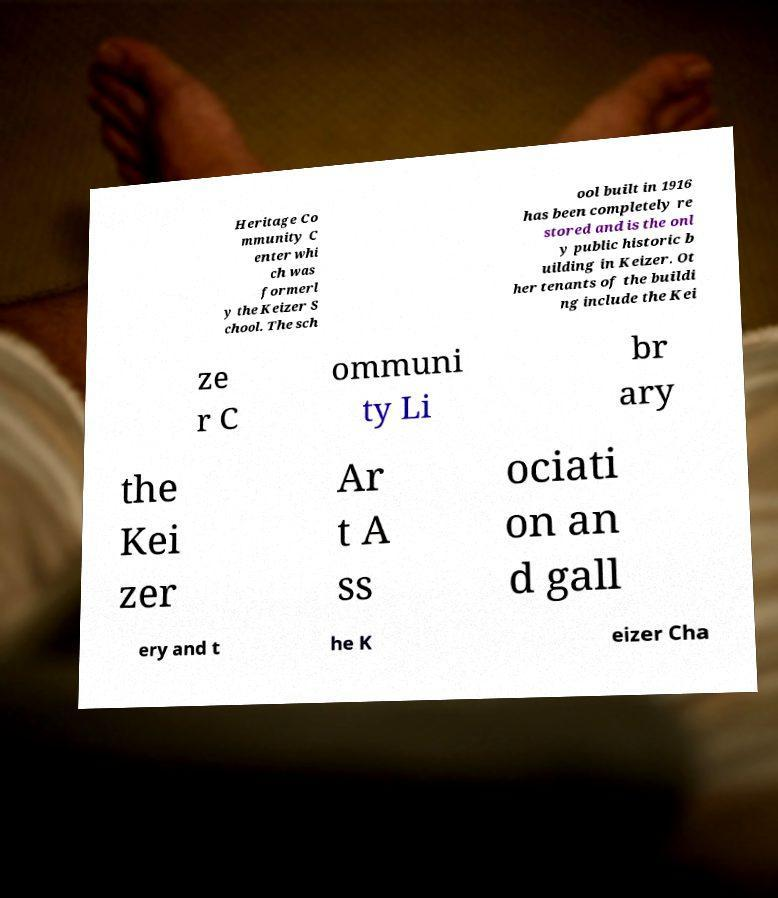Please read and relay the text visible in this image. What does it say? Heritage Co mmunity C enter whi ch was formerl y the Keizer S chool. The sch ool built in 1916 has been completely re stored and is the onl y public historic b uilding in Keizer. Ot her tenants of the buildi ng include the Kei ze r C ommuni ty Li br ary the Kei zer Ar t A ss ociati on an d gall ery and t he K eizer Cha 